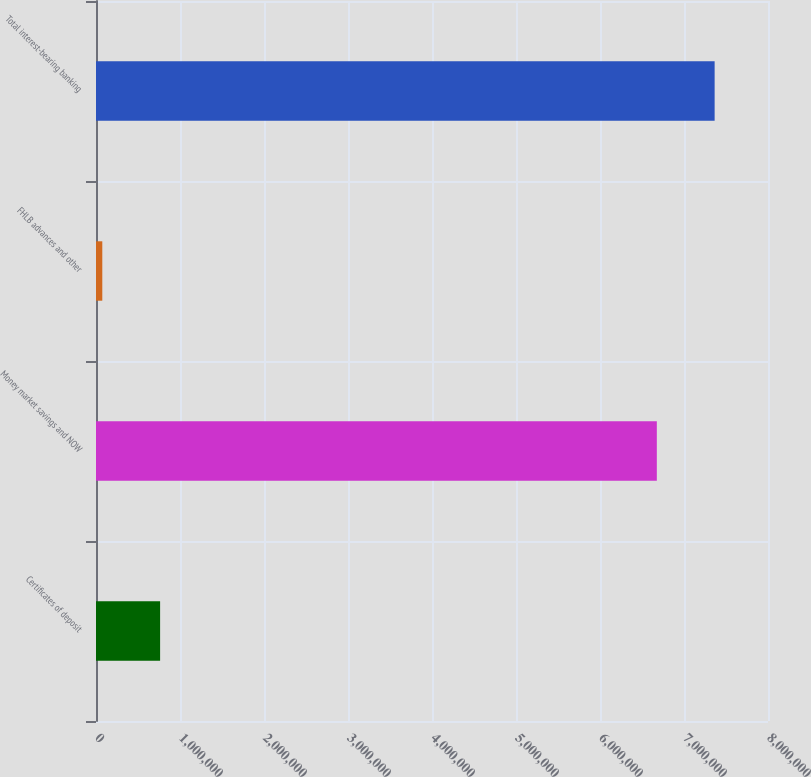Convert chart to OTSL. <chart><loc_0><loc_0><loc_500><loc_500><bar_chart><fcel>Certificates of deposit<fcel>Money market savings and NOW<fcel>FHLB advances and other<fcel>Total interest-bearing banking<nl><fcel>763179<fcel>6.6764e+06<fcel>74925<fcel>7.36465e+06<nl></chart> 